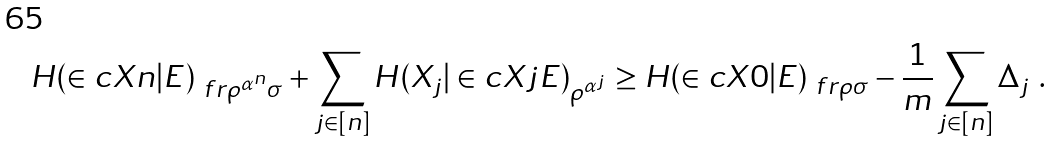Convert formula to latex. <formula><loc_0><loc_0><loc_500><loc_500>H ( \in c { X } { n } | E ) _ { \ f r { \rho ^ { \alpha ^ { n } } } { \sigma } } + \sum _ { j \in [ n ] } H ( X _ { j } | \in c { X } { j } E ) _ { \rho ^ { \alpha ^ { j } } } \geq H ( \in c { X } { 0 } | E ) _ { \ f r { \rho } { \sigma } } - \frac { 1 } { m } \sum _ { j \in [ n ] } \Delta _ { j } \ .</formula> 